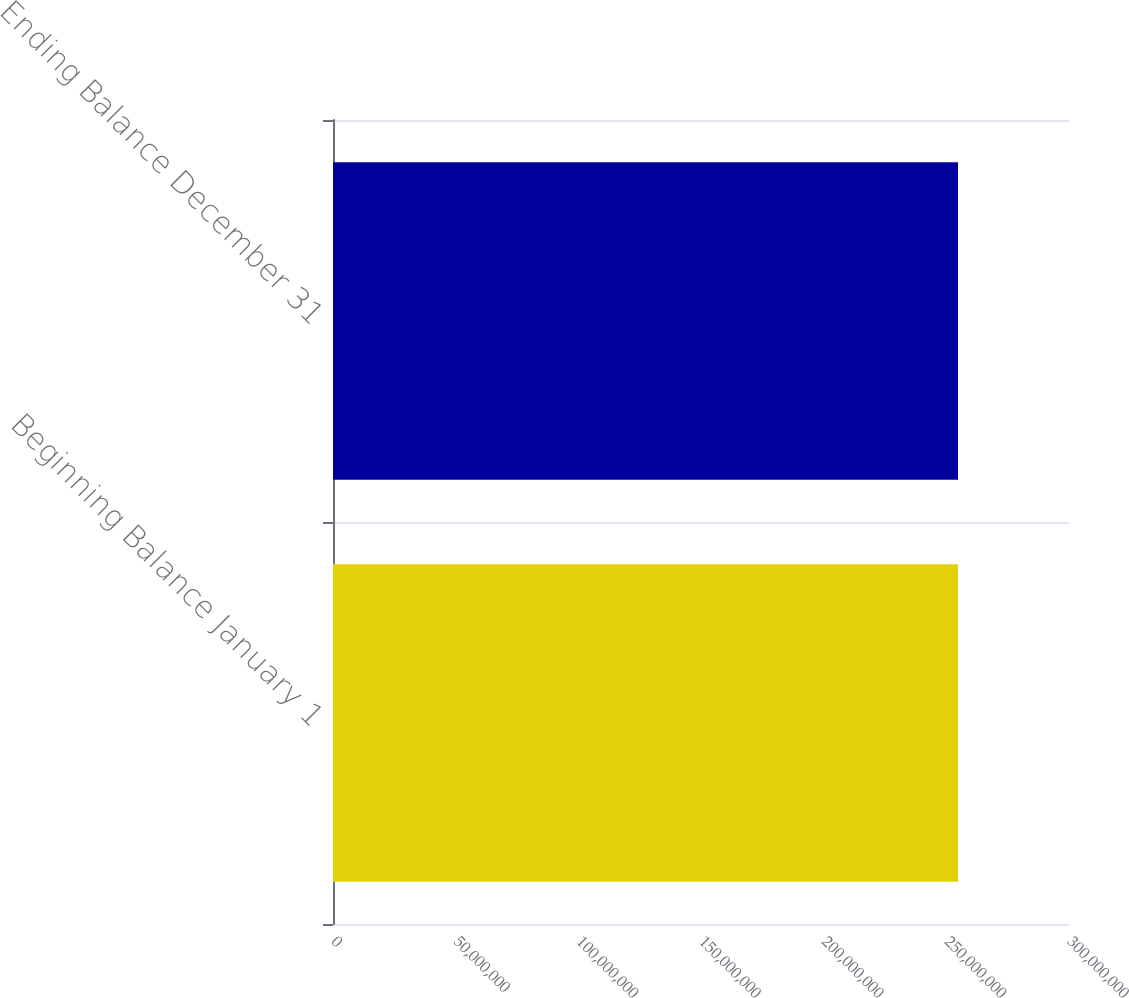Convert chart to OTSL. <chart><loc_0><loc_0><loc_500><loc_500><bar_chart><fcel>Beginning Balance January 1<fcel>Ending Balance December 31<nl><fcel>2.54753e+08<fcel>2.54753e+08<nl></chart> 